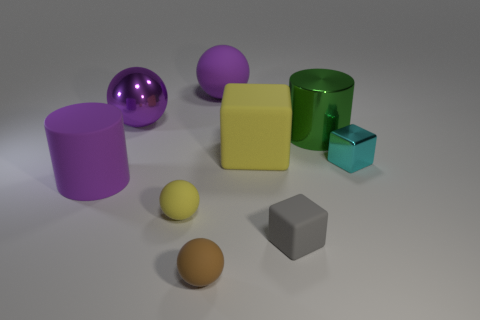What number of tiny yellow objects are behind the large purple object that is in front of the large green metallic object?
Your answer should be compact. 0. Is there a large rubber cube that has the same color as the matte cylinder?
Offer a very short reply. No. Do the green metallic thing and the purple shiny sphere have the same size?
Give a very brief answer. Yes. Does the metal block have the same color as the big shiny sphere?
Make the answer very short. No. What material is the big cylinder that is to the left of the matte block that is in front of the yellow rubber sphere made of?
Give a very brief answer. Rubber. There is another small thing that is the same shape as the brown object; what material is it?
Give a very brief answer. Rubber. Does the yellow rubber object in front of the cyan metal thing have the same size as the brown rubber thing?
Ensure brevity in your answer.  Yes. How many rubber objects are either objects or purple cylinders?
Your answer should be compact. 6. What is the small object that is both right of the brown rubber ball and in front of the rubber cylinder made of?
Provide a short and direct response. Rubber. Does the brown ball have the same material as the small gray object?
Your answer should be compact. Yes. 